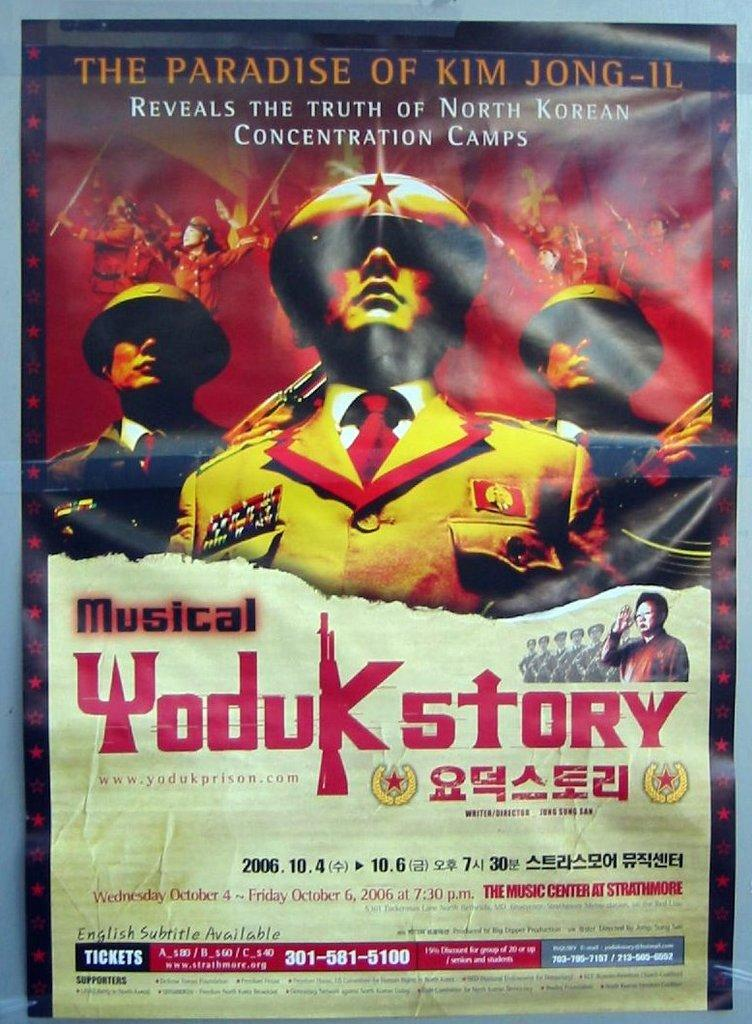<image>
Give a short and clear explanation of the subsequent image. A red and yellow movie poster shows Kim Jong-Il. 